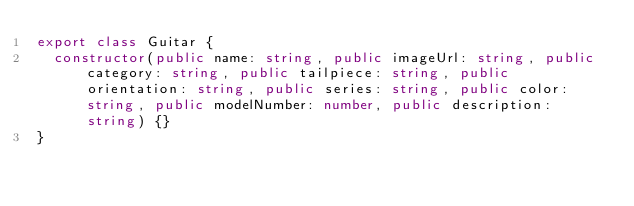<code> <loc_0><loc_0><loc_500><loc_500><_TypeScript_>export class Guitar {
  constructor(public name: string, public imageUrl: string, public category: string, public tailpiece: string, public orientation: string, public series: string, public color: string, public modelNumber: number, public description: string) {}
}
</code> 